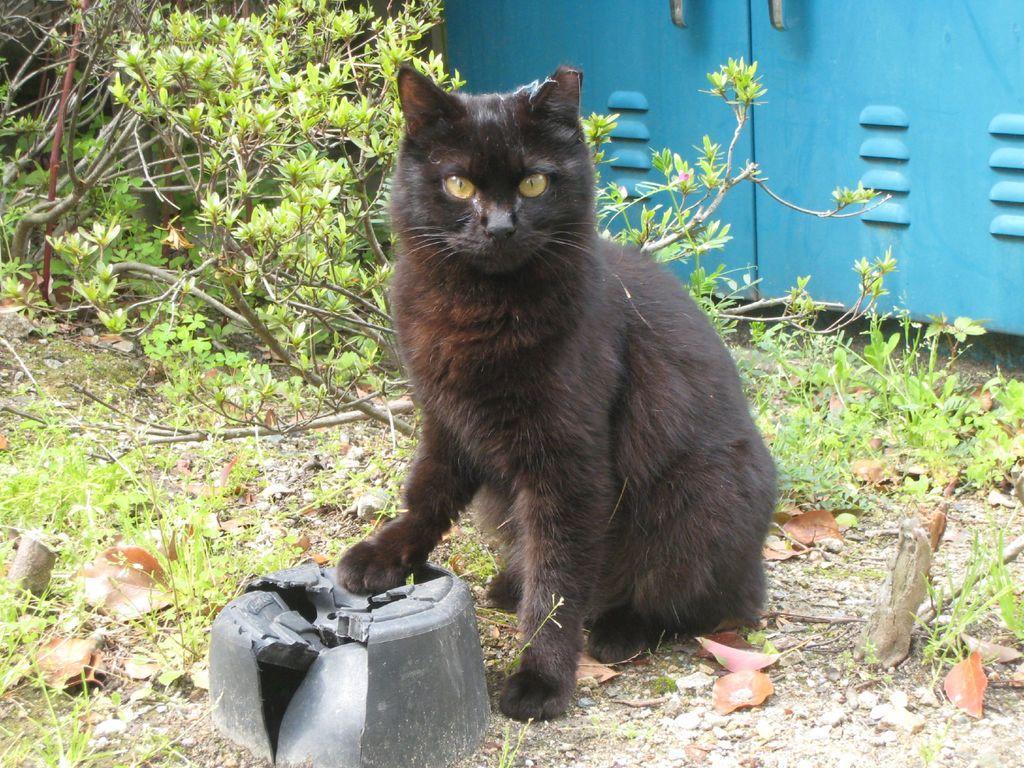Can you describe this image briefly? This picture shows a black cat and we see trees and a metal box on the side and we see grass on the ground. 